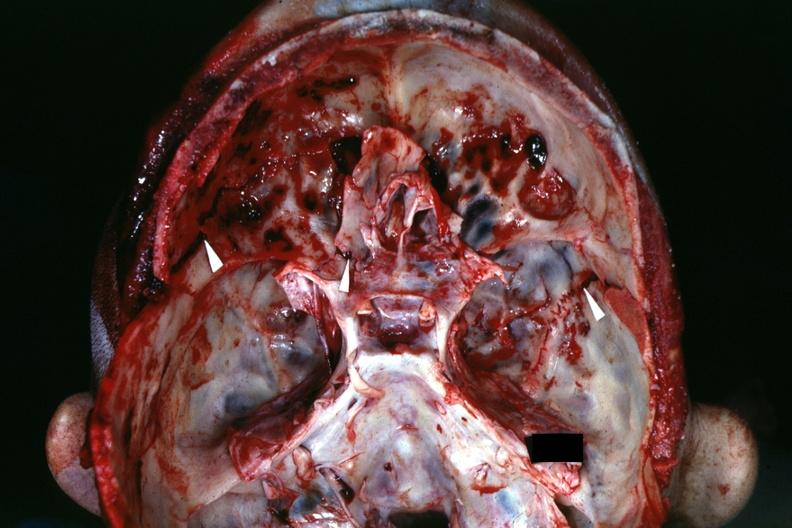does exostosis show view of base of skull with several well shown fractures?
Answer the question using a single word or phrase. No 